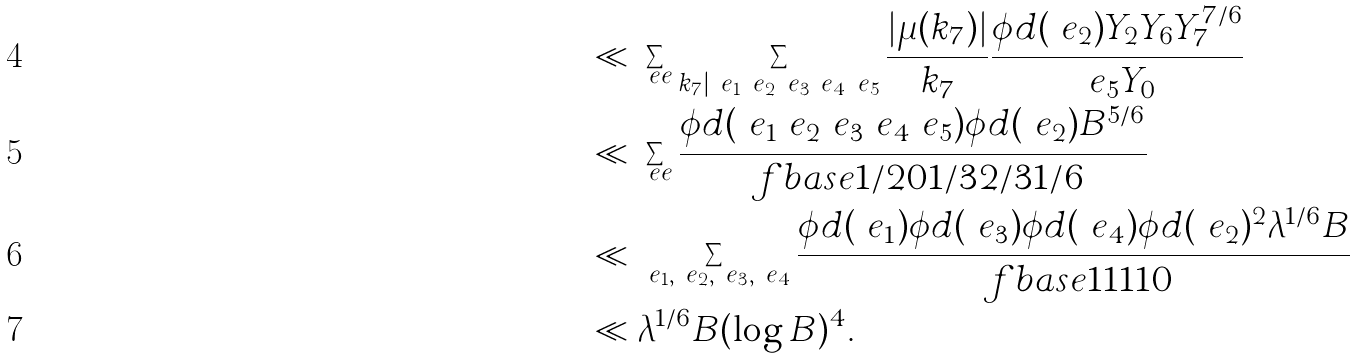<formula> <loc_0><loc_0><loc_500><loc_500>& \ll \sum _ { \ e e } \sum _ { k _ { 7 } | \ e _ { 1 } \ e _ { 2 } \ e _ { 3 } \ e _ { 4 } \ e _ { 5 } } \frac { | \mu ( k _ { 7 } ) | } { k _ { 7 } } \frac { \phi d ( \ e _ { 2 } ) Y _ { 2 } Y _ { 6 } Y _ { 7 } ^ { 7 / 6 } } { \ e _ { 5 } Y _ { 0 } } \\ & \ll \sum _ { \ e e } \frac { \phi d ( \ e _ { 1 } \ e _ { 2 } \ e _ { 3 } \ e _ { 4 } \ e _ { 5 } ) \phi d ( \ e _ { 2 } ) B ^ { 5 / 6 } } { \ f b a s e { 1 / 2 } { 0 } { 1 / 3 } { 2 / 3 } { 1 / 6 } } \\ & \ll \sum _ { \ e _ { 1 } , \ e _ { 2 } , \ e _ { 3 } , \ e _ { 4 } } \frac { \phi d ( \ e _ { 1 } ) \phi d ( \ e _ { 3 } ) \phi d ( \ e _ { 4 } ) \phi d ( \ e _ { 2 } ) ^ { 2 } \lambda ^ { 1 / 6 } B } { \ f b a s e 1 1 1 1 0 } \\ & \ll \lambda ^ { 1 / 6 } B ( \log B ) ^ { 4 } .</formula> 